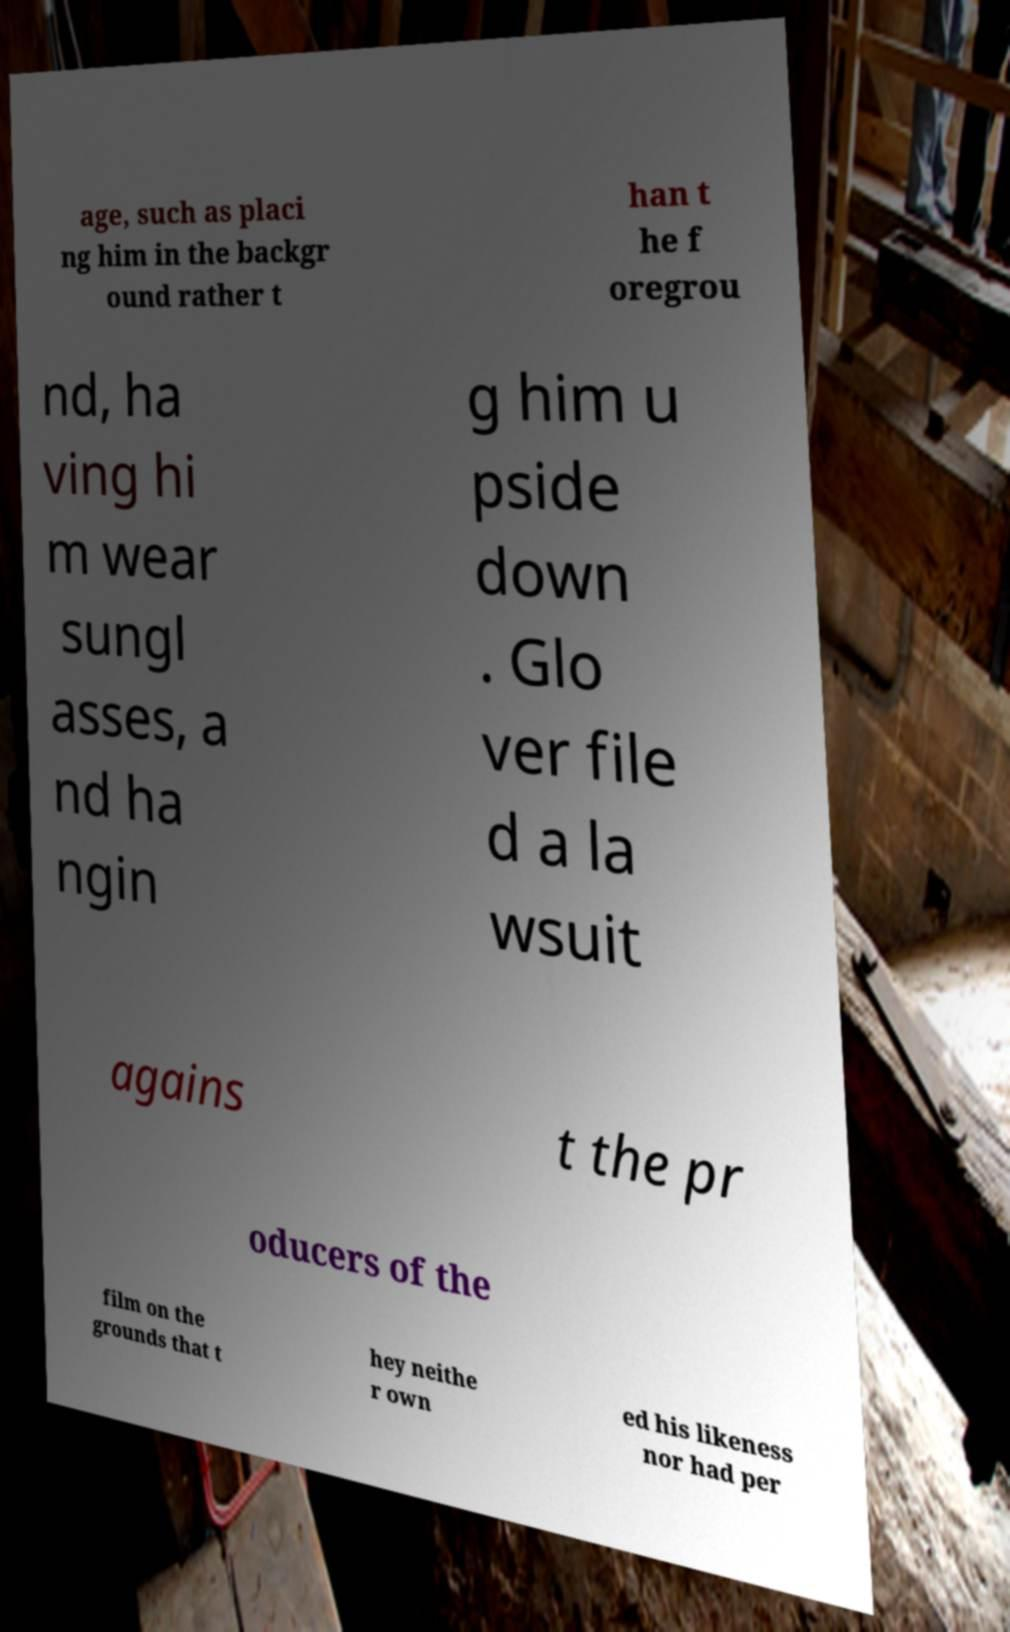For documentation purposes, I need the text within this image transcribed. Could you provide that? age, such as placi ng him in the backgr ound rather t han t he f oregrou nd, ha ving hi m wear sungl asses, a nd ha ngin g him u pside down . Glo ver file d a la wsuit agains t the pr oducers of the film on the grounds that t hey neithe r own ed his likeness nor had per 